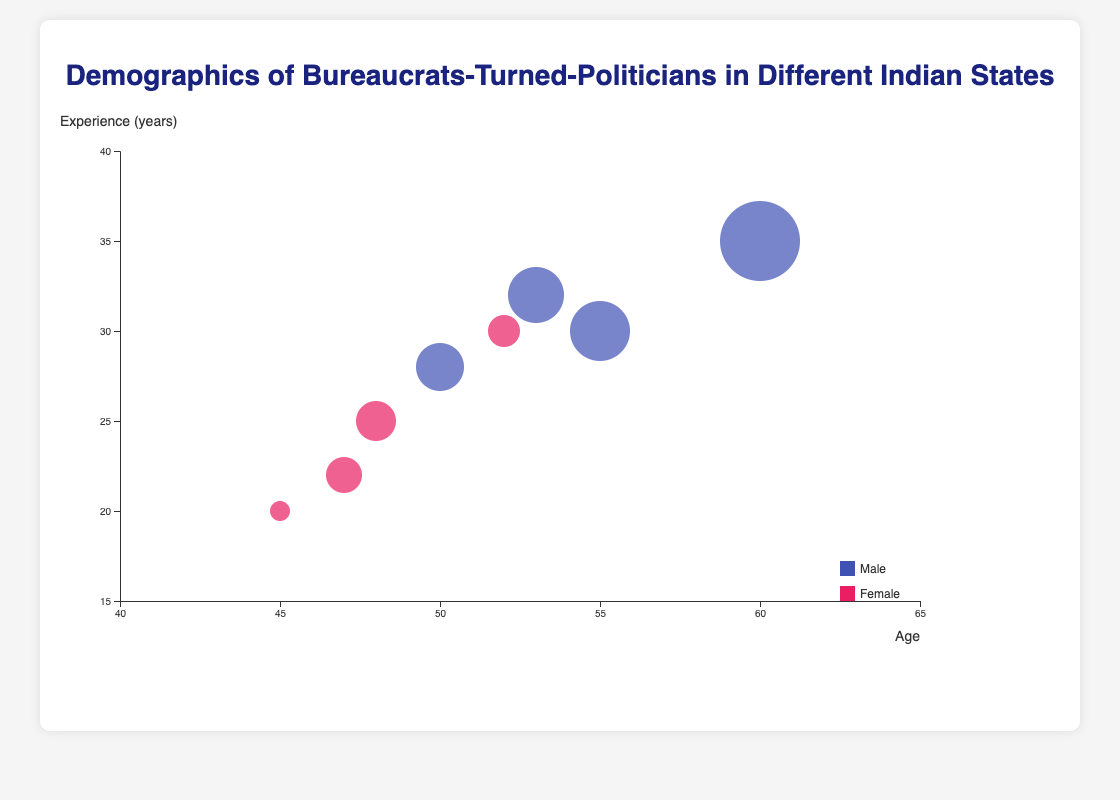What is the average age of the female bureaucrats-turned-politicians? Find the ages of the female bureaucrats-turned-politicians: Snehal Deshmukh (45), Priya Menon (48), Bindu Krishnamurthy (52), and Anjali Verma (47). Then calculate the average: (45 + 48 + 52 + 47) / 4 = 192 / 4 = 48
Answer: 48 Which state has the bureaucrat-turned-politician with the highest influence factor, and what is that factor? Look at the influence factor for each bureaucrat-turned-politician. Raghavendra Singh from Uttar Pradesh has the highest influence factor at 80.
Answer: Uttar Pradesh, 80 What is the age and experience of the bureaucrat-turned-politician from Maharashtra? The chart shows Snehal Deshmukh from Maharashtra. Her age is 45, and her experience is 20 years.
Answer: Age: 45, Experience: 20 years Compare the experience of the youngest and the oldest bureaucrats-turned-politicians. What is their experience difference? The youngest is Snehal Deshmukh (45) with 20 years of experience, and the oldest is Raghavendra Singh (60) with 35 years of experience. Difference in experience: 35 - 20 = 15 years.
Answer: 15 years Which age group is more represented, those above 50 years or those below 50 years? Count the number of bureaucrats-turned-politicians above and below 50 years. Above 50 years: Anbu Muthu, Subrata Roy, Bindu Krishnamurthy, Manoj Gupta, and Raghavendra Singh (5). Below 50 years: Snehal Deshmukh, Priya Menon, and Anjali Verma (3).
Answer: Above 50 years Identify the bureaucrat-turned-politician with the least influence factor. Locate the bureaucrats-turned-politicians with the smallest size bubbles. Snehal Deshmukh from Maharashtra has the least influence factor of 65.
Answer: Snehal Deshmukh, 65 How does experience correlate with the size of bubbles in general? Using the data, observe the trend of bubble sizes (influence factors) with respect to years of experience. Generally, those with more experience have larger bubbles, suggesting a positive correlation between experience and influence factor.
Answer: Positive correlation 